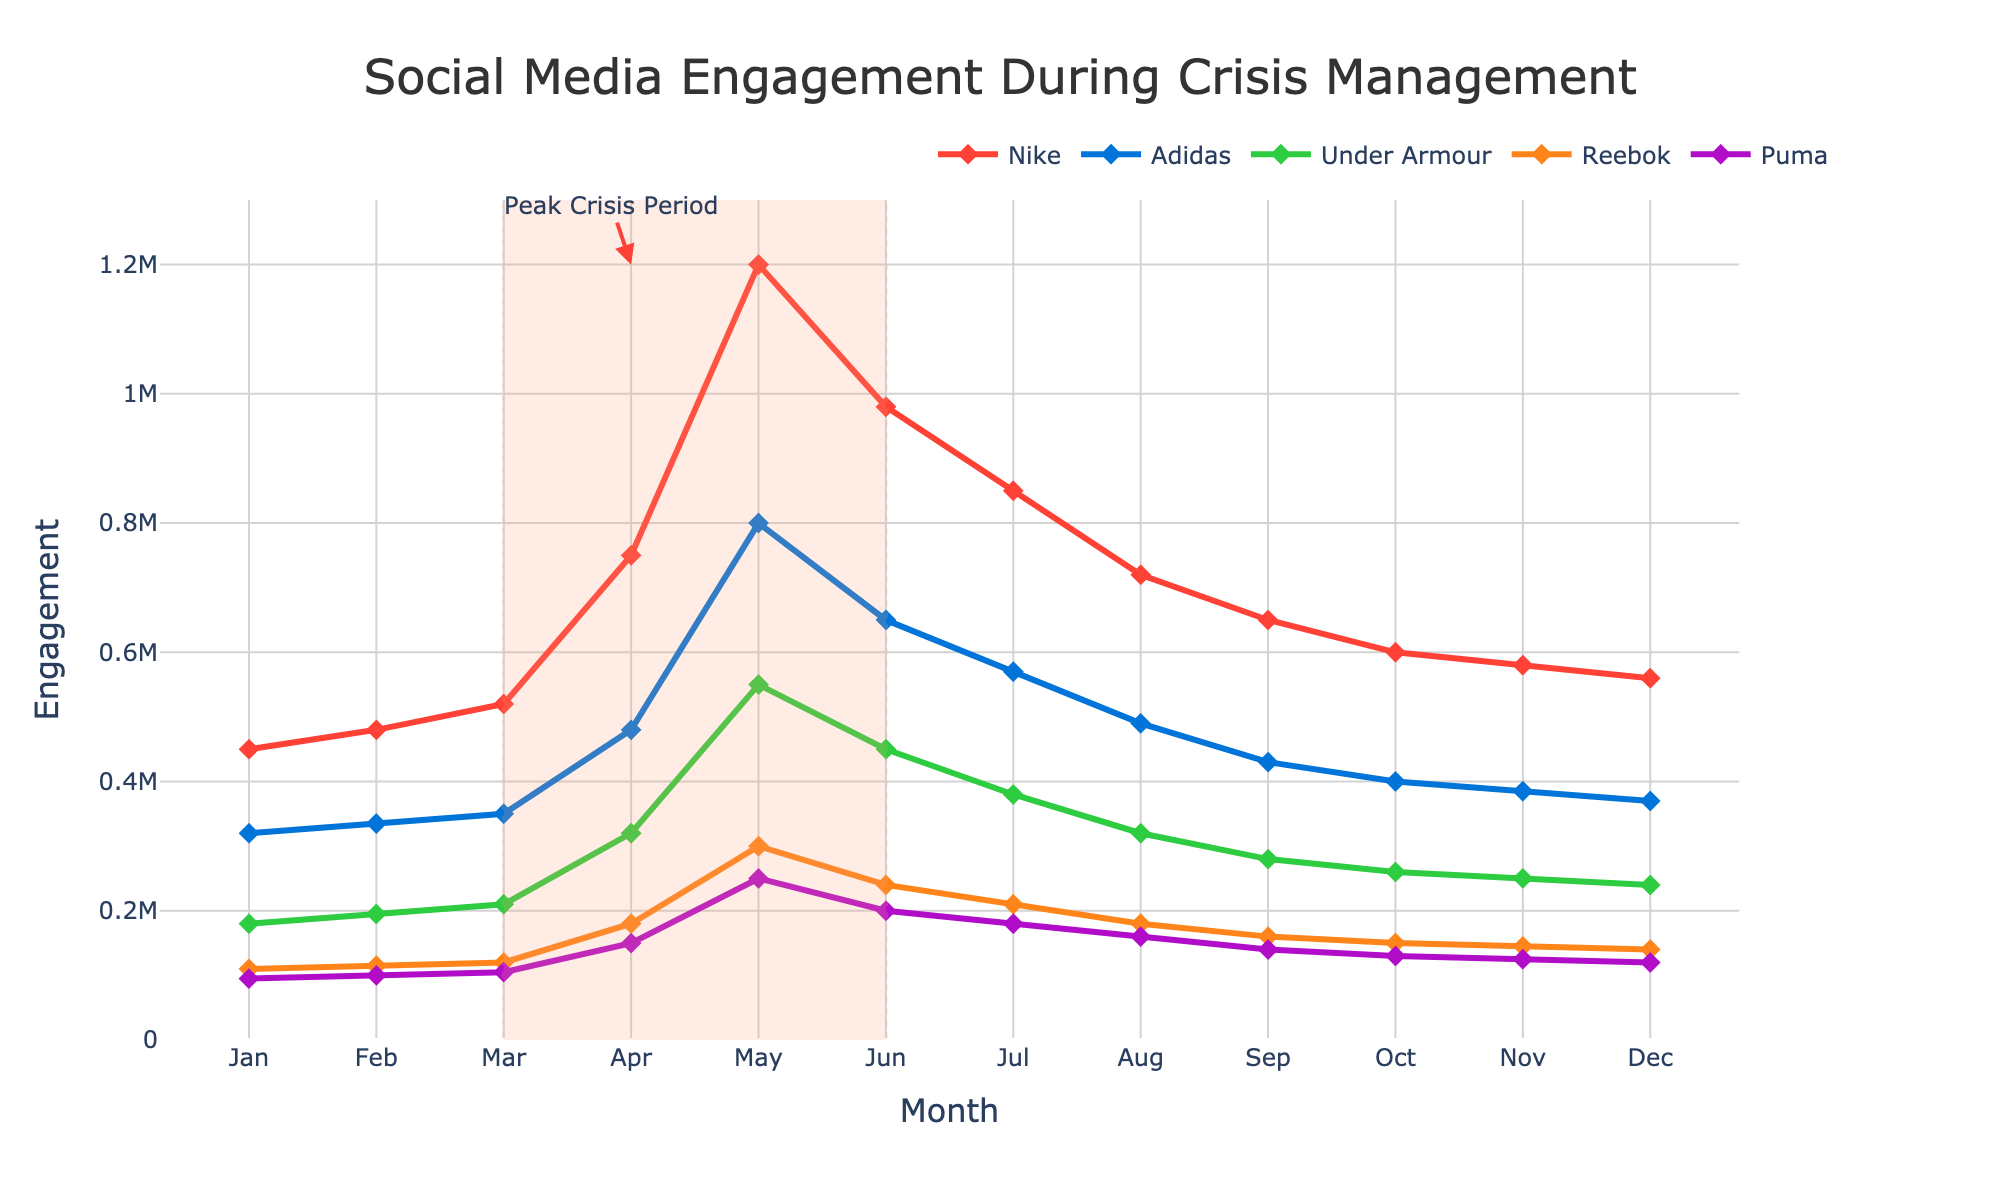What is the peak engagement for Nike and in which month did it occur? Nike's engagement reached its peak during the month of May. The value can be confirmed by observing the highest point on the graph for Nike, which aligns with May on the x-axis.
Answer: 1,200,000; May Which brand had the lowest engagement in December and what was the value? By looking at December, the lowest line among all brands belongs to Puma. Checking the specific value on the y-axis, Puma's engagement in December was 120,000.
Answer: Puma; 120,000 How did the engagement for Reebok in June compare to July? Reebok's engagement in June was 240,000 and in July it dropped to 210,000. Subtracting July's value from June's gives us a decrease of 30,000.
Answer: Decreased by 30,000 What is the average engagement for Adidas during the months of April, May, and June? To find the average engagement for Adidas during these months, sum up the values for April (480,000), May (800,000), and June (650,000) and divide by 3. This amounts to (480,000 + 800,000 + 650,000) / 3 = 1,930,000 / 3 which is approximately 643,333.33.
Answer: 643,333.33 Which brand showed the most consistent (least variable) engagement pattern throughout the year? To determine consistency, observe the lines that show the least fluctuation in height throughout the year. Under Armour's line is relatively smoother and shows less variation compared to others.
Answer: Under Armour How does Nike's engagement in August compare to April? Nike's engagement in April was 750,000 while in August it was 720,000. Comparing these values, April's engagement was higher by 30,000.
Answer: April was higher by 30,000 During which months did the engagement for Puma exceed 100,000? By tracing the blue line for Puma, engagement exceeded 100,000 between April and December.
Answer: April to December What is the combined engagement for all brands in March? Sum up the engagement values for March across all brands: Nike (520,000) + Adidas (350,000) + Under Armour (210,000) + Reebok (120,000) + Puma (105,000). This results in 1,305,000.
Answer: 1,305,000 Identify the month in which all brands show a declining trend starting from the peak observed during the crisis period. After the peak crisis period in May, all brands show a consistent decline starting from July as indicated by the downward slope in their respective engagement values.
Answer: July During the peak crisis period, which brand experienced the largest drop in engagement from its peak value the subsequent month? Check the month following the peak crisis period in May. Nike's engagement dropped from 1,200,000 in May to 980,000 in June, a difference of 220,000. For Adidas, the drop was from 800,000 to 650,000, a difference of 150,000, and so forth for all brands showing Nike had the largest drop.
Answer: Nike; 220,000 